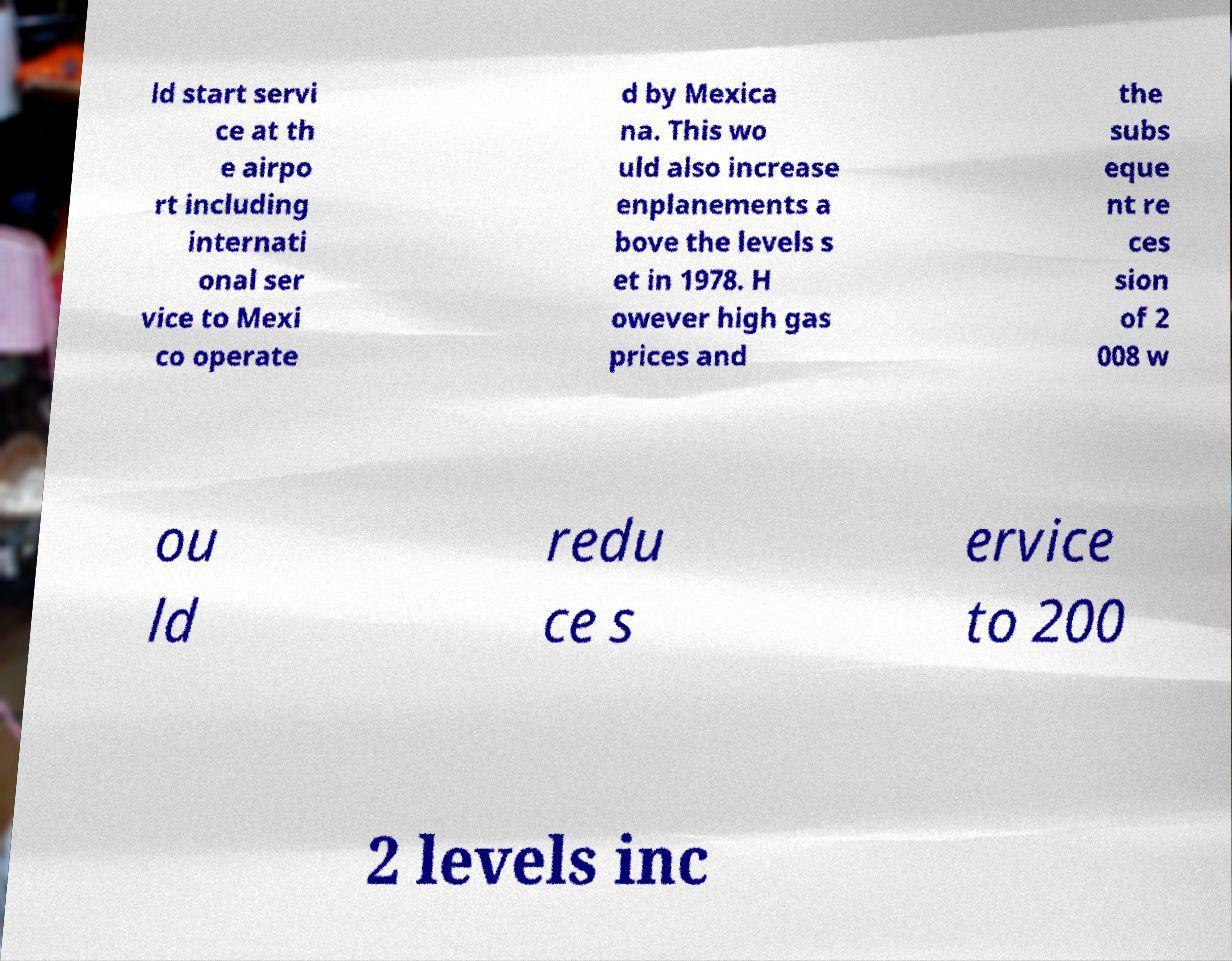Can you accurately transcribe the text from the provided image for me? ld start servi ce at th e airpo rt including internati onal ser vice to Mexi co operate d by Mexica na. This wo uld also increase enplanements a bove the levels s et in 1978. H owever high gas prices and the subs eque nt re ces sion of 2 008 w ou ld redu ce s ervice to 200 2 levels inc 